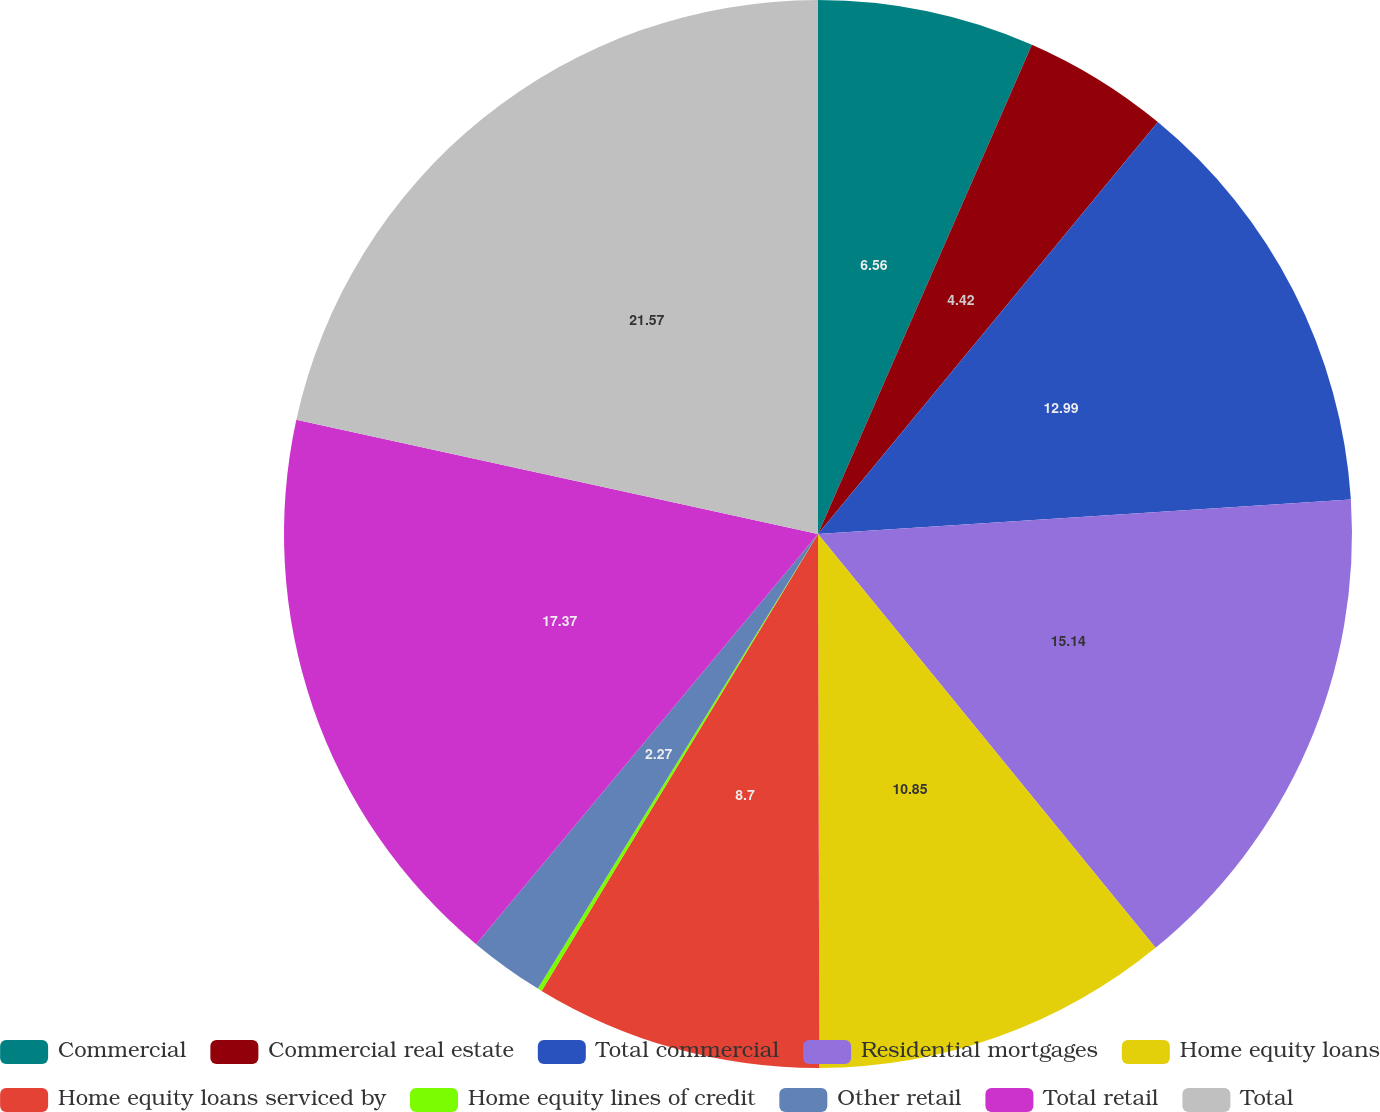Convert chart. <chart><loc_0><loc_0><loc_500><loc_500><pie_chart><fcel>Commercial<fcel>Commercial real estate<fcel>Total commercial<fcel>Residential mortgages<fcel>Home equity loans<fcel>Home equity loans serviced by<fcel>Home equity lines of credit<fcel>Other retail<fcel>Total retail<fcel>Total<nl><fcel>6.56%<fcel>4.42%<fcel>12.99%<fcel>15.14%<fcel>10.85%<fcel>8.7%<fcel>0.13%<fcel>2.27%<fcel>17.37%<fcel>21.57%<nl></chart> 